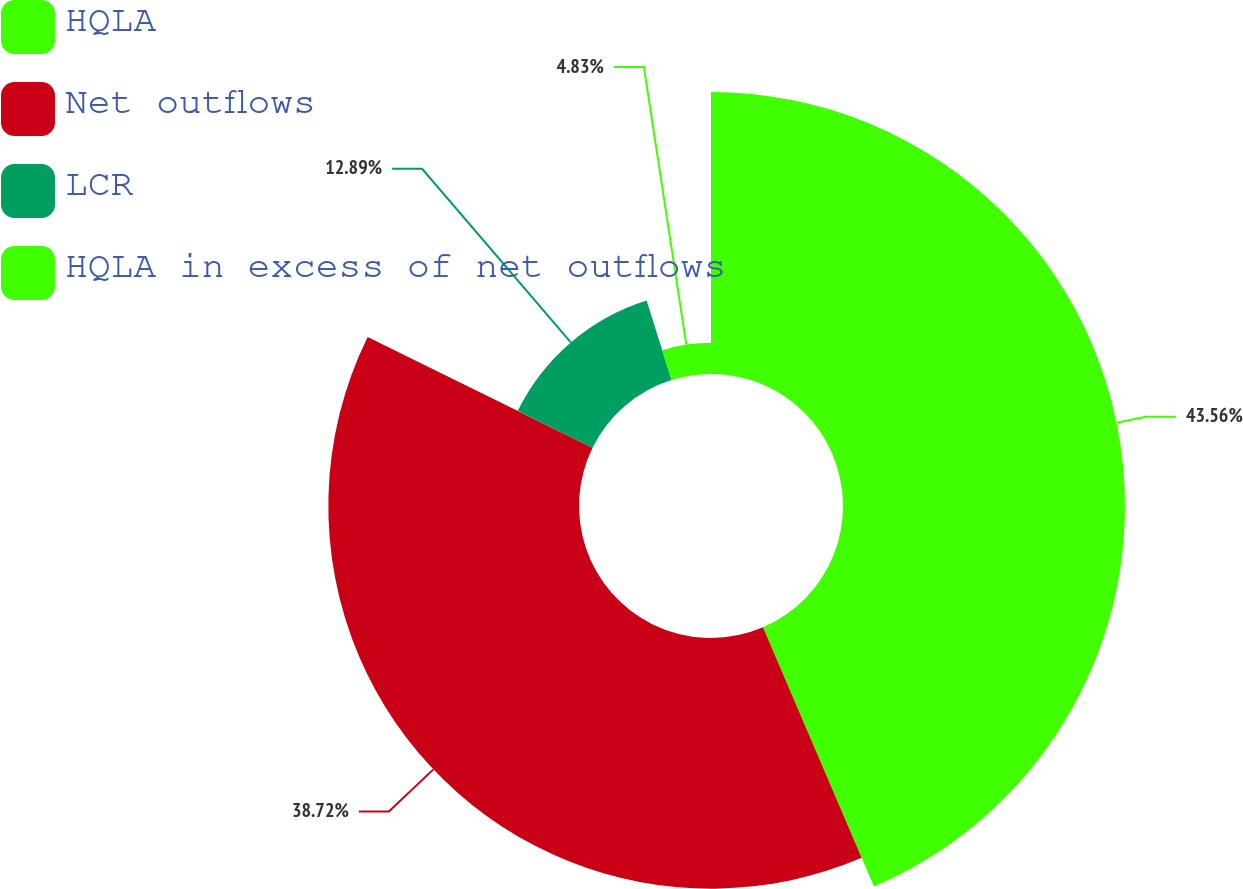Convert chart. <chart><loc_0><loc_0><loc_500><loc_500><pie_chart><fcel>HQLA<fcel>Net outflows<fcel>LCR<fcel>HQLA in excess of net outflows<nl><fcel>43.56%<fcel>38.72%<fcel>12.89%<fcel>4.83%<nl></chart> 